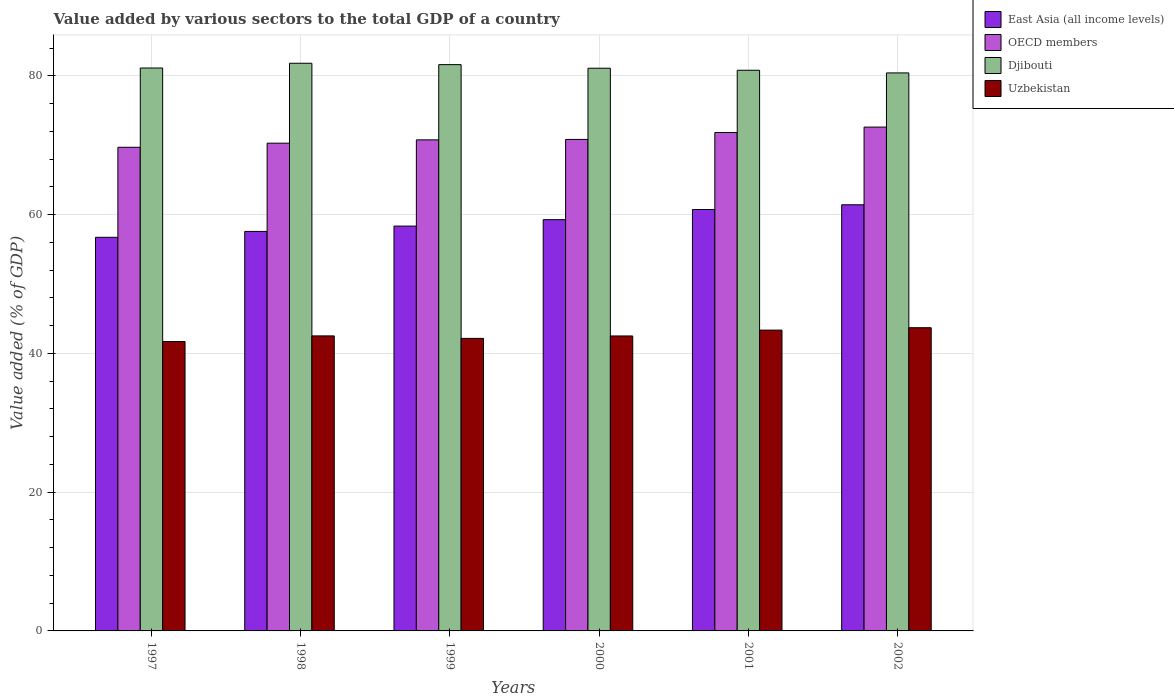Are the number of bars per tick equal to the number of legend labels?
Ensure brevity in your answer.  Yes. How many bars are there on the 6th tick from the left?
Give a very brief answer. 4. How many bars are there on the 5th tick from the right?
Give a very brief answer. 4. What is the label of the 6th group of bars from the left?
Your answer should be very brief. 2002. What is the value added by various sectors to the total GDP in Uzbekistan in 1999?
Ensure brevity in your answer.  42.17. Across all years, what is the maximum value added by various sectors to the total GDP in OECD members?
Provide a short and direct response. 72.62. Across all years, what is the minimum value added by various sectors to the total GDP in Djibouti?
Offer a very short reply. 80.43. What is the total value added by various sectors to the total GDP in Uzbekistan in the graph?
Offer a terse response. 255.98. What is the difference between the value added by various sectors to the total GDP in OECD members in 1997 and that in 1998?
Ensure brevity in your answer.  -0.59. What is the difference between the value added by various sectors to the total GDP in OECD members in 1997 and the value added by various sectors to the total GDP in Uzbekistan in 2002?
Give a very brief answer. 26.01. What is the average value added by various sectors to the total GDP in East Asia (all income levels) per year?
Give a very brief answer. 59.02. In the year 1997, what is the difference between the value added by various sectors to the total GDP in East Asia (all income levels) and value added by various sectors to the total GDP in OECD members?
Keep it short and to the point. -12.98. What is the ratio of the value added by various sectors to the total GDP in Uzbekistan in 1998 to that in 1999?
Ensure brevity in your answer.  1.01. Is the value added by various sectors to the total GDP in OECD members in 1999 less than that in 2002?
Your answer should be compact. Yes. What is the difference between the highest and the second highest value added by various sectors to the total GDP in Djibouti?
Ensure brevity in your answer.  0.2. What is the difference between the highest and the lowest value added by various sectors to the total GDP in East Asia (all income levels)?
Provide a short and direct response. 4.69. Is the sum of the value added by various sectors to the total GDP in OECD members in 1998 and 1999 greater than the maximum value added by various sectors to the total GDP in Uzbekistan across all years?
Your answer should be very brief. Yes. Is it the case that in every year, the sum of the value added by various sectors to the total GDP in Djibouti and value added by various sectors to the total GDP in East Asia (all income levels) is greater than the sum of value added by various sectors to the total GDP in Uzbekistan and value added by various sectors to the total GDP in OECD members?
Your response must be concise. No. What does the 3rd bar from the left in 1999 represents?
Ensure brevity in your answer.  Djibouti. What does the 2nd bar from the right in 2001 represents?
Provide a short and direct response. Djibouti. Is it the case that in every year, the sum of the value added by various sectors to the total GDP in Djibouti and value added by various sectors to the total GDP in Uzbekistan is greater than the value added by various sectors to the total GDP in OECD members?
Keep it short and to the point. Yes. What is the difference between two consecutive major ticks on the Y-axis?
Make the answer very short. 20. Does the graph contain any zero values?
Keep it short and to the point. No. Does the graph contain grids?
Provide a short and direct response. Yes. How many legend labels are there?
Your answer should be compact. 4. What is the title of the graph?
Your answer should be very brief. Value added by various sectors to the total GDP of a country. What is the label or title of the X-axis?
Your response must be concise. Years. What is the label or title of the Y-axis?
Make the answer very short. Value added (% of GDP). What is the Value added (% of GDP) of East Asia (all income levels) in 1997?
Ensure brevity in your answer.  56.73. What is the Value added (% of GDP) of OECD members in 1997?
Your answer should be compact. 69.71. What is the Value added (% of GDP) in Djibouti in 1997?
Keep it short and to the point. 81.14. What is the Value added (% of GDP) in Uzbekistan in 1997?
Offer a terse response. 41.71. What is the Value added (% of GDP) of East Asia (all income levels) in 1998?
Ensure brevity in your answer.  57.58. What is the Value added (% of GDP) in OECD members in 1998?
Provide a short and direct response. 70.3. What is the Value added (% of GDP) of Djibouti in 1998?
Offer a very short reply. 81.82. What is the Value added (% of GDP) of Uzbekistan in 1998?
Make the answer very short. 42.52. What is the Value added (% of GDP) of East Asia (all income levels) in 1999?
Your answer should be very brief. 58.35. What is the Value added (% of GDP) of OECD members in 1999?
Ensure brevity in your answer.  70.78. What is the Value added (% of GDP) in Djibouti in 1999?
Make the answer very short. 81.62. What is the Value added (% of GDP) in Uzbekistan in 1999?
Provide a succinct answer. 42.17. What is the Value added (% of GDP) in East Asia (all income levels) in 2000?
Your answer should be compact. 59.28. What is the Value added (% of GDP) in OECD members in 2000?
Your response must be concise. 70.84. What is the Value added (% of GDP) of Djibouti in 2000?
Your answer should be compact. 81.1. What is the Value added (% of GDP) of Uzbekistan in 2000?
Ensure brevity in your answer.  42.51. What is the Value added (% of GDP) of East Asia (all income levels) in 2001?
Your response must be concise. 60.74. What is the Value added (% of GDP) in OECD members in 2001?
Your response must be concise. 71.84. What is the Value added (% of GDP) of Djibouti in 2001?
Give a very brief answer. 80.81. What is the Value added (% of GDP) of Uzbekistan in 2001?
Give a very brief answer. 43.36. What is the Value added (% of GDP) in East Asia (all income levels) in 2002?
Make the answer very short. 61.42. What is the Value added (% of GDP) in OECD members in 2002?
Provide a succinct answer. 72.62. What is the Value added (% of GDP) of Djibouti in 2002?
Provide a short and direct response. 80.43. What is the Value added (% of GDP) of Uzbekistan in 2002?
Ensure brevity in your answer.  43.7. Across all years, what is the maximum Value added (% of GDP) of East Asia (all income levels)?
Offer a terse response. 61.42. Across all years, what is the maximum Value added (% of GDP) of OECD members?
Make the answer very short. 72.62. Across all years, what is the maximum Value added (% of GDP) in Djibouti?
Your answer should be very brief. 81.82. Across all years, what is the maximum Value added (% of GDP) of Uzbekistan?
Offer a terse response. 43.7. Across all years, what is the minimum Value added (% of GDP) of East Asia (all income levels)?
Offer a terse response. 56.73. Across all years, what is the minimum Value added (% of GDP) in OECD members?
Provide a succinct answer. 69.71. Across all years, what is the minimum Value added (% of GDP) of Djibouti?
Provide a short and direct response. 80.43. Across all years, what is the minimum Value added (% of GDP) in Uzbekistan?
Your answer should be compact. 41.71. What is the total Value added (% of GDP) of East Asia (all income levels) in the graph?
Offer a terse response. 354.11. What is the total Value added (% of GDP) of OECD members in the graph?
Make the answer very short. 426.1. What is the total Value added (% of GDP) of Djibouti in the graph?
Offer a terse response. 486.92. What is the total Value added (% of GDP) in Uzbekistan in the graph?
Ensure brevity in your answer.  255.98. What is the difference between the Value added (% of GDP) of East Asia (all income levels) in 1997 and that in 1998?
Offer a terse response. -0.85. What is the difference between the Value added (% of GDP) of OECD members in 1997 and that in 1998?
Keep it short and to the point. -0.59. What is the difference between the Value added (% of GDP) of Djibouti in 1997 and that in 1998?
Make the answer very short. -0.68. What is the difference between the Value added (% of GDP) of Uzbekistan in 1997 and that in 1998?
Offer a very short reply. -0.81. What is the difference between the Value added (% of GDP) in East Asia (all income levels) in 1997 and that in 1999?
Ensure brevity in your answer.  -1.62. What is the difference between the Value added (% of GDP) in OECD members in 1997 and that in 1999?
Your answer should be compact. -1.07. What is the difference between the Value added (% of GDP) in Djibouti in 1997 and that in 1999?
Make the answer very short. -0.49. What is the difference between the Value added (% of GDP) in Uzbekistan in 1997 and that in 1999?
Keep it short and to the point. -0.45. What is the difference between the Value added (% of GDP) of East Asia (all income levels) in 1997 and that in 2000?
Your response must be concise. -2.54. What is the difference between the Value added (% of GDP) of OECD members in 1997 and that in 2000?
Your answer should be compact. -1.13. What is the difference between the Value added (% of GDP) of Djibouti in 1997 and that in 2000?
Give a very brief answer. 0.03. What is the difference between the Value added (% of GDP) in Uzbekistan in 1997 and that in 2000?
Your answer should be very brief. -0.8. What is the difference between the Value added (% of GDP) in East Asia (all income levels) in 1997 and that in 2001?
Your response must be concise. -4.01. What is the difference between the Value added (% of GDP) in OECD members in 1997 and that in 2001?
Make the answer very short. -2.13. What is the difference between the Value added (% of GDP) of Djibouti in 1997 and that in 2001?
Your answer should be compact. 0.32. What is the difference between the Value added (% of GDP) in Uzbekistan in 1997 and that in 2001?
Make the answer very short. -1.65. What is the difference between the Value added (% of GDP) in East Asia (all income levels) in 1997 and that in 2002?
Your response must be concise. -4.69. What is the difference between the Value added (% of GDP) in OECD members in 1997 and that in 2002?
Make the answer very short. -2.91. What is the difference between the Value added (% of GDP) in Djibouti in 1997 and that in 2002?
Your response must be concise. 0.71. What is the difference between the Value added (% of GDP) of Uzbekistan in 1997 and that in 2002?
Your response must be concise. -1.99. What is the difference between the Value added (% of GDP) of East Asia (all income levels) in 1998 and that in 1999?
Ensure brevity in your answer.  -0.77. What is the difference between the Value added (% of GDP) in OECD members in 1998 and that in 1999?
Offer a very short reply. -0.48. What is the difference between the Value added (% of GDP) in Djibouti in 1998 and that in 1999?
Provide a short and direct response. 0.2. What is the difference between the Value added (% of GDP) of Uzbekistan in 1998 and that in 1999?
Your answer should be very brief. 0.36. What is the difference between the Value added (% of GDP) in East Asia (all income levels) in 1998 and that in 2000?
Offer a terse response. -1.69. What is the difference between the Value added (% of GDP) of OECD members in 1998 and that in 2000?
Provide a short and direct response. -0.54. What is the difference between the Value added (% of GDP) in Djibouti in 1998 and that in 2000?
Provide a succinct answer. 0.72. What is the difference between the Value added (% of GDP) in Uzbekistan in 1998 and that in 2000?
Your answer should be very brief. 0.01. What is the difference between the Value added (% of GDP) of East Asia (all income levels) in 1998 and that in 2001?
Offer a terse response. -3.16. What is the difference between the Value added (% of GDP) of OECD members in 1998 and that in 2001?
Give a very brief answer. -1.54. What is the difference between the Value added (% of GDP) of Djibouti in 1998 and that in 2001?
Ensure brevity in your answer.  1.01. What is the difference between the Value added (% of GDP) in Uzbekistan in 1998 and that in 2001?
Keep it short and to the point. -0.83. What is the difference between the Value added (% of GDP) in East Asia (all income levels) in 1998 and that in 2002?
Provide a succinct answer. -3.84. What is the difference between the Value added (% of GDP) in OECD members in 1998 and that in 2002?
Offer a very short reply. -2.32. What is the difference between the Value added (% of GDP) in Djibouti in 1998 and that in 2002?
Provide a short and direct response. 1.39. What is the difference between the Value added (% of GDP) of Uzbekistan in 1998 and that in 2002?
Provide a succinct answer. -1.18. What is the difference between the Value added (% of GDP) of East Asia (all income levels) in 1999 and that in 2000?
Your answer should be compact. -0.93. What is the difference between the Value added (% of GDP) of OECD members in 1999 and that in 2000?
Offer a very short reply. -0.06. What is the difference between the Value added (% of GDP) of Djibouti in 1999 and that in 2000?
Make the answer very short. 0.52. What is the difference between the Value added (% of GDP) in Uzbekistan in 1999 and that in 2000?
Provide a short and direct response. -0.35. What is the difference between the Value added (% of GDP) of East Asia (all income levels) in 1999 and that in 2001?
Your answer should be very brief. -2.39. What is the difference between the Value added (% of GDP) of OECD members in 1999 and that in 2001?
Offer a terse response. -1.06. What is the difference between the Value added (% of GDP) of Djibouti in 1999 and that in 2001?
Your answer should be very brief. 0.81. What is the difference between the Value added (% of GDP) of Uzbekistan in 1999 and that in 2001?
Your answer should be compact. -1.19. What is the difference between the Value added (% of GDP) of East Asia (all income levels) in 1999 and that in 2002?
Your answer should be compact. -3.07. What is the difference between the Value added (% of GDP) in OECD members in 1999 and that in 2002?
Give a very brief answer. -1.84. What is the difference between the Value added (% of GDP) of Djibouti in 1999 and that in 2002?
Your response must be concise. 1.19. What is the difference between the Value added (% of GDP) in Uzbekistan in 1999 and that in 2002?
Make the answer very short. -1.54. What is the difference between the Value added (% of GDP) of East Asia (all income levels) in 2000 and that in 2001?
Make the answer very short. -1.46. What is the difference between the Value added (% of GDP) of OECD members in 2000 and that in 2001?
Provide a succinct answer. -1. What is the difference between the Value added (% of GDP) of Djibouti in 2000 and that in 2001?
Keep it short and to the point. 0.29. What is the difference between the Value added (% of GDP) of Uzbekistan in 2000 and that in 2001?
Your answer should be compact. -0.84. What is the difference between the Value added (% of GDP) of East Asia (all income levels) in 2000 and that in 2002?
Make the answer very short. -2.15. What is the difference between the Value added (% of GDP) of OECD members in 2000 and that in 2002?
Provide a short and direct response. -1.78. What is the difference between the Value added (% of GDP) of Djibouti in 2000 and that in 2002?
Offer a terse response. 0.67. What is the difference between the Value added (% of GDP) in Uzbekistan in 2000 and that in 2002?
Offer a terse response. -1.19. What is the difference between the Value added (% of GDP) of East Asia (all income levels) in 2001 and that in 2002?
Offer a very short reply. -0.68. What is the difference between the Value added (% of GDP) of OECD members in 2001 and that in 2002?
Ensure brevity in your answer.  -0.78. What is the difference between the Value added (% of GDP) of Djibouti in 2001 and that in 2002?
Provide a short and direct response. 0.38. What is the difference between the Value added (% of GDP) of Uzbekistan in 2001 and that in 2002?
Make the answer very short. -0.35. What is the difference between the Value added (% of GDP) in East Asia (all income levels) in 1997 and the Value added (% of GDP) in OECD members in 1998?
Give a very brief answer. -13.57. What is the difference between the Value added (% of GDP) in East Asia (all income levels) in 1997 and the Value added (% of GDP) in Djibouti in 1998?
Provide a short and direct response. -25.09. What is the difference between the Value added (% of GDP) of East Asia (all income levels) in 1997 and the Value added (% of GDP) of Uzbekistan in 1998?
Ensure brevity in your answer.  14.21. What is the difference between the Value added (% of GDP) in OECD members in 1997 and the Value added (% of GDP) in Djibouti in 1998?
Offer a terse response. -12.11. What is the difference between the Value added (% of GDP) of OECD members in 1997 and the Value added (% of GDP) of Uzbekistan in 1998?
Your answer should be compact. 27.19. What is the difference between the Value added (% of GDP) of Djibouti in 1997 and the Value added (% of GDP) of Uzbekistan in 1998?
Ensure brevity in your answer.  38.61. What is the difference between the Value added (% of GDP) of East Asia (all income levels) in 1997 and the Value added (% of GDP) of OECD members in 1999?
Your answer should be compact. -14.05. What is the difference between the Value added (% of GDP) of East Asia (all income levels) in 1997 and the Value added (% of GDP) of Djibouti in 1999?
Provide a succinct answer. -24.89. What is the difference between the Value added (% of GDP) of East Asia (all income levels) in 1997 and the Value added (% of GDP) of Uzbekistan in 1999?
Your answer should be very brief. 14.57. What is the difference between the Value added (% of GDP) of OECD members in 1997 and the Value added (% of GDP) of Djibouti in 1999?
Ensure brevity in your answer.  -11.91. What is the difference between the Value added (% of GDP) in OECD members in 1997 and the Value added (% of GDP) in Uzbekistan in 1999?
Give a very brief answer. 27.54. What is the difference between the Value added (% of GDP) in Djibouti in 1997 and the Value added (% of GDP) in Uzbekistan in 1999?
Keep it short and to the point. 38.97. What is the difference between the Value added (% of GDP) in East Asia (all income levels) in 1997 and the Value added (% of GDP) in OECD members in 2000?
Offer a very short reply. -14.11. What is the difference between the Value added (% of GDP) in East Asia (all income levels) in 1997 and the Value added (% of GDP) in Djibouti in 2000?
Provide a short and direct response. -24.37. What is the difference between the Value added (% of GDP) in East Asia (all income levels) in 1997 and the Value added (% of GDP) in Uzbekistan in 2000?
Give a very brief answer. 14.22. What is the difference between the Value added (% of GDP) in OECD members in 1997 and the Value added (% of GDP) in Djibouti in 2000?
Your answer should be very brief. -11.39. What is the difference between the Value added (% of GDP) in OECD members in 1997 and the Value added (% of GDP) in Uzbekistan in 2000?
Provide a succinct answer. 27.2. What is the difference between the Value added (% of GDP) of Djibouti in 1997 and the Value added (% of GDP) of Uzbekistan in 2000?
Your answer should be very brief. 38.62. What is the difference between the Value added (% of GDP) in East Asia (all income levels) in 1997 and the Value added (% of GDP) in OECD members in 2001?
Provide a short and direct response. -15.11. What is the difference between the Value added (% of GDP) in East Asia (all income levels) in 1997 and the Value added (% of GDP) in Djibouti in 2001?
Keep it short and to the point. -24.08. What is the difference between the Value added (% of GDP) in East Asia (all income levels) in 1997 and the Value added (% of GDP) in Uzbekistan in 2001?
Your answer should be compact. 13.38. What is the difference between the Value added (% of GDP) in OECD members in 1997 and the Value added (% of GDP) in Djibouti in 2001?
Provide a succinct answer. -11.1. What is the difference between the Value added (% of GDP) in OECD members in 1997 and the Value added (% of GDP) in Uzbekistan in 2001?
Ensure brevity in your answer.  26.35. What is the difference between the Value added (% of GDP) of Djibouti in 1997 and the Value added (% of GDP) of Uzbekistan in 2001?
Provide a short and direct response. 37.78. What is the difference between the Value added (% of GDP) of East Asia (all income levels) in 1997 and the Value added (% of GDP) of OECD members in 2002?
Your response must be concise. -15.89. What is the difference between the Value added (% of GDP) in East Asia (all income levels) in 1997 and the Value added (% of GDP) in Djibouti in 2002?
Your answer should be compact. -23.7. What is the difference between the Value added (% of GDP) of East Asia (all income levels) in 1997 and the Value added (% of GDP) of Uzbekistan in 2002?
Your answer should be compact. 13.03. What is the difference between the Value added (% of GDP) of OECD members in 1997 and the Value added (% of GDP) of Djibouti in 2002?
Give a very brief answer. -10.72. What is the difference between the Value added (% of GDP) in OECD members in 1997 and the Value added (% of GDP) in Uzbekistan in 2002?
Offer a very short reply. 26.01. What is the difference between the Value added (% of GDP) of Djibouti in 1997 and the Value added (% of GDP) of Uzbekistan in 2002?
Your answer should be very brief. 37.43. What is the difference between the Value added (% of GDP) in East Asia (all income levels) in 1998 and the Value added (% of GDP) in OECD members in 1999?
Offer a terse response. -13.2. What is the difference between the Value added (% of GDP) in East Asia (all income levels) in 1998 and the Value added (% of GDP) in Djibouti in 1999?
Give a very brief answer. -24.04. What is the difference between the Value added (% of GDP) of East Asia (all income levels) in 1998 and the Value added (% of GDP) of Uzbekistan in 1999?
Provide a succinct answer. 15.42. What is the difference between the Value added (% of GDP) of OECD members in 1998 and the Value added (% of GDP) of Djibouti in 1999?
Make the answer very short. -11.32. What is the difference between the Value added (% of GDP) of OECD members in 1998 and the Value added (% of GDP) of Uzbekistan in 1999?
Your answer should be very brief. 28.14. What is the difference between the Value added (% of GDP) in Djibouti in 1998 and the Value added (% of GDP) in Uzbekistan in 1999?
Provide a succinct answer. 39.65. What is the difference between the Value added (% of GDP) in East Asia (all income levels) in 1998 and the Value added (% of GDP) in OECD members in 2000?
Provide a short and direct response. -13.26. What is the difference between the Value added (% of GDP) of East Asia (all income levels) in 1998 and the Value added (% of GDP) of Djibouti in 2000?
Your answer should be very brief. -23.52. What is the difference between the Value added (% of GDP) of East Asia (all income levels) in 1998 and the Value added (% of GDP) of Uzbekistan in 2000?
Give a very brief answer. 15.07. What is the difference between the Value added (% of GDP) in OECD members in 1998 and the Value added (% of GDP) in Uzbekistan in 2000?
Provide a short and direct response. 27.79. What is the difference between the Value added (% of GDP) in Djibouti in 1998 and the Value added (% of GDP) in Uzbekistan in 2000?
Offer a terse response. 39.3. What is the difference between the Value added (% of GDP) in East Asia (all income levels) in 1998 and the Value added (% of GDP) in OECD members in 2001?
Make the answer very short. -14.26. What is the difference between the Value added (% of GDP) of East Asia (all income levels) in 1998 and the Value added (% of GDP) of Djibouti in 2001?
Ensure brevity in your answer.  -23.23. What is the difference between the Value added (% of GDP) in East Asia (all income levels) in 1998 and the Value added (% of GDP) in Uzbekistan in 2001?
Your answer should be very brief. 14.23. What is the difference between the Value added (% of GDP) in OECD members in 1998 and the Value added (% of GDP) in Djibouti in 2001?
Your response must be concise. -10.51. What is the difference between the Value added (% of GDP) of OECD members in 1998 and the Value added (% of GDP) of Uzbekistan in 2001?
Offer a terse response. 26.95. What is the difference between the Value added (% of GDP) of Djibouti in 1998 and the Value added (% of GDP) of Uzbekistan in 2001?
Provide a succinct answer. 38.46. What is the difference between the Value added (% of GDP) in East Asia (all income levels) in 1998 and the Value added (% of GDP) in OECD members in 2002?
Offer a very short reply. -15.04. What is the difference between the Value added (% of GDP) in East Asia (all income levels) in 1998 and the Value added (% of GDP) in Djibouti in 2002?
Give a very brief answer. -22.85. What is the difference between the Value added (% of GDP) in East Asia (all income levels) in 1998 and the Value added (% of GDP) in Uzbekistan in 2002?
Provide a short and direct response. 13.88. What is the difference between the Value added (% of GDP) in OECD members in 1998 and the Value added (% of GDP) in Djibouti in 2002?
Ensure brevity in your answer.  -10.13. What is the difference between the Value added (% of GDP) of OECD members in 1998 and the Value added (% of GDP) of Uzbekistan in 2002?
Ensure brevity in your answer.  26.6. What is the difference between the Value added (% of GDP) of Djibouti in 1998 and the Value added (% of GDP) of Uzbekistan in 2002?
Make the answer very short. 38.12. What is the difference between the Value added (% of GDP) in East Asia (all income levels) in 1999 and the Value added (% of GDP) in OECD members in 2000?
Keep it short and to the point. -12.49. What is the difference between the Value added (% of GDP) in East Asia (all income levels) in 1999 and the Value added (% of GDP) in Djibouti in 2000?
Provide a succinct answer. -22.75. What is the difference between the Value added (% of GDP) in East Asia (all income levels) in 1999 and the Value added (% of GDP) in Uzbekistan in 2000?
Your answer should be very brief. 15.84. What is the difference between the Value added (% of GDP) of OECD members in 1999 and the Value added (% of GDP) of Djibouti in 2000?
Your response must be concise. -10.32. What is the difference between the Value added (% of GDP) in OECD members in 1999 and the Value added (% of GDP) in Uzbekistan in 2000?
Provide a succinct answer. 28.27. What is the difference between the Value added (% of GDP) in Djibouti in 1999 and the Value added (% of GDP) in Uzbekistan in 2000?
Ensure brevity in your answer.  39.11. What is the difference between the Value added (% of GDP) in East Asia (all income levels) in 1999 and the Value added (% of GDP) in OECD members in 2001?
Keep it short and to the point. -13.49. What is the difference between the Value added (% of GDP) in East Asia (all income levels) in 1999 and the Value added (% of GDP) in Djibouti in 2001?
Your answer should be compact. -22.46. What is the difference between the Value added (% of GDP) in East Asia (all income levels) in 1999 and the Value added (% of GDP) in Uzbekistan in 2001?
Provide a short and direct response. 14.99. What is the difference between the Value added (% of GDP) of OECD members in 1999 and the Value added (% of GDP) of Djibouti in 2001?
Make the answer very short. -10.03. What is the difference between the Value added (% of GDP) of OECD members in 1999 and the Value added (% of GDP) of Uzbekistan in 2001?
Provide a succinct answer. 27.42. What is the difference between the Value added (% of GDP) of Djibouti in 1999 and the Value added (% of GDP) of Uzbekistan in 2001?
Your answer should be compact. 38.26. What is the difference between the Value added (% of GDP) in East Asia (all income levels) in 1999 and the Value added (% of GDP) in OECD members in 2002?
Provide a succinct answer. -14.27. What is the difference between the Value added (% of GDP) of East Asia (all income levels) in 1999 and the Value added (% of GDP) of Djibouti in 2002?
Provide a succinct answer. -22.08. What is the difference between the Value added (% of GDP) in East Asia (all income levels) in 1999 and the Value added (% of GDP) in Uzbekistan in 2002?
Offer a very short reply. 14.65. What is the difference between the Value added (% of GDP) in OECD members in 1999 and the Value added (% of GDP) in Djibouti in 2002?
Keep it short and to the point. -9.65. What is the difference between the Value added (% of GDP) in OECD members in 1999 and the Value added (% of GDP) in Uzbekistan in 2002?
Provide a short and direct response. 27.08. What is the difference between the Value added (% of GDP) of Djibouti in 1999 and the Value added (% of GDP) of Uzbekistan in 2002?
Your answer should be compact. 37.92. What is the difference between the Value added (% of GDP) in East Asia (all income levels) in 2000 and the Value added (% of GDP) in OECD members in 2001?
Make the answer very short. -12.56. What is the difference between the Value added (% of GDP) of East Asia (all income levels) in 2000 and the Value added (% of GDP) of Djibouti in 2001?
Make the answer very short. -21.54. What is the difference between the Value added (% of GDP) of East Asia (all income levels) in 2000 and the Value added (% of GDP) of Uzbekistan in 2001?
Offer a very short reply. 15.92. What is the difference between the Value added (% of GDP) in OECD members in 2000 and the Value added (% of GDP) in Djibouti in 2001?
Offer a terse response. -9.97. What is the difference between the Value added (% of GDP) in OECD members in 2000 and the Value added (% of GDP) in Uzbekistan in 2001?
Make the answer very short. 27.49. What is the difference between the Value added (% of GDP) of Djibouti in 2000 and the Value added (% of GDP) of Uzbekistan in 2001?
Offer a very short reply. 37.75. What is the difference between the Value added (% of GDP) of East Asia (all income levels) in 2000 and the Value added (% of GDP) of OECD members in 2002?
Offer a terse response. -13.34. What is the difference between the Value added (% of GDP) of East Asia (all income levels) in 2000 and the Value added (% of GDP) of Djibouti in 2002?
Provide a succinct answer. -21.15. What is the difference between the Value added (% of GDP) of East Asia (all income levels) in 2000 and the Value added (% of GDP) of Uzbekistan in 2002?
Provide a short and direct response. 15.57. What is the difference between the Value added (% of GDP) of OECD members in 2000 and the Value added (% of GDP) of Djibouti in 2002?
Keep it short and to the point. -9.59. What is the difference between the Value added (% of GDP) in OECD members in 2000 and the Value added (% of GDP) in Uzbekistan in 2002?
Offer a terse response. 27.14. What is the difference between the Value added (% of GDP) of Djibouti in 2000 and the Value added (% of GDP) of Uzbekistan in 2002?
Make the answer very short. 37.4. What is the difference between the Value added (% of GDP) of East Asia (all income levels) in 2001 and the Value added (% of GDP) of OECD members in 2002?
Offer a terse response. -11.88. What is the difference between the Value added (% of GDP) in East Asia (all income levels) in 2001 and the Value added (% of GDP) in Djibouti in 2002?
Your answer should be compact. -19.69. What is the difference between the Value added (% of GDP) of East Asia (all income levels) in 2001 and the Value added (% of GDP) of Uzbekistan in 2002?
Ensure brevity in your answer.  17.04. What is the difference between the Value added (% of GDP) of OECD members in 2001 and the Value added (% of GDP) of Djibouti in 2002?
Ensure brevity in your answer.  -8.59. What is the difference between the Value added (% of GDP) in OECD members in 2001 and the Value added (% of GDP) in Uzbekistan in 2002?
Your answer should be very brief. 28.14. What is the difference between the Value added (% of GDP) in Djibouti in 2001 and the Value added (% of GDP) in Uzbekistan in 2002?
Your answer should be very brief. 37.11. What is the average Value added (% of GDP) of East Asia (all income levels) per year?
Ensure brevity in your answer.  59.02. What is the average Value added (% of GDP) of OECD members per year?
Your answer should be compact. 71.02. What is the average Value added (% of GDP) of Djibouti per year?
Your answer should be very brief. 81.15. What is the average Value added (% of GDP) of Uzbekistan per year?
Your response must be concise. 42.66. In the year 1997, what is the difference between the Value added (% of GDP) of East Asia (all income levels) and Value added (% of GDP) of OECD members?
Provide a short and direct response. -12.98. In the year 1997, what is the difference between the Value added (% of GDP) of East Asia (all income levels) and Value added (% of GDP) of Djibouti?
Offer a very short reply. -24.4. In the year 1997, what is the difference between the Value added (% of GDP) of East Asia (all income levels) and Value added (% of GDP) of Uzbekistan?
Ensure brevity in your answer.  15.02. In the year 1997, what is the difference between the Value added (% of GDP) in OECD members and Value added (% of GDP) in Djibouti?
Provide a short and direct response. -11.42. In the year 1997, what is the difference between the Value added (% of GDP) in OECD members and Value added (% of GDP) in Uzbekistan?
Provide a short and direct response. 28. In the year 1997, what is the difference between the Value added (% of GDP) in Djibouti and Value added (% of GDP) in Uzbekistan?
Your answer should be compact. 39.42. In the year 1998, what is the difference between the Value added (% of GDP) of East Asia (all income levels) and Value added (% of GDP) of OECD members?
Provide a short and direct response. -12.72. In the year 1998, what is the difference between the Value added (% of GDP) of East Asia (all income levels) and Value added (% of GDP) of Djibouti?
Make the answer very short. -24.24. In the year 1998, what is the difference between the Value added (% of GDP) in East Asia (all income levels) and Value added (% of GDP) in Uzbekistan?
Offer a very short reply. 15.06. In the year 1998, what is the difference between the Value added (% of GDP) in OECD members and Value added (% of GDP) in Djibouti?
Offer a very short reply. -11.52. In the year 1998, what is the difference between the Value added (% of GDP) in OECD members and Value added (% of GDP) in Uzbekistan?
Provide a short and direct response. 27.78. In the year 1998, what is the difference between the Value added (% of GDP) in Djibouti and Value added (% of GDP) in Uzbekistan?
Provide a succinct answer. 39.3. In the year 1999, what is the difference between the Value added (% of GDP) in East Asia (all income levels) and Value added (% of GDP) in OECD members?
Give a very brief answer. -12.43. In the year 1999, what is the difference between the Value added (% of GDP) of East Asia (all income levels) and Value added (% of GDP) of Djibouti?
Ensure brevity in your answer.  -23.27. In the year 1999, what is the difference between the Value added (% of GDP) of East Asia (all income levels) and Value added (% of GDP) of Uzbekistan?
Provide a succinct answer. 16.18. In the year 1999, what is the difference between the Value added (% of GDP) in OECD members and Value added (% of GDP) in Djibouti?
Provide a short and direct response. -10.84. In the year 1999, what is the difference between the Value added (% of GDP) in OECD members and Value added (% of GDP) in Uzbekistan?
Your answer should be very brief. 28.61. In the year 1999, what is the difference between the Value added (% of GDP) in Djibouti and Value added (% of GDP) in Uzbekistan?
Offer a very short reply. 39.46. In the year 2000, what is the difference between the Value added (% of GDP) in East Asia (all income levels) and Value added (% of GDP) in OECD members?
Offer a very short reply. -11.57. In the year 2000, what is the difference between the Value added (% of GDP) of East Asia (all income levels) and Value added (% of GDP) of Djibouti?
Offer a terse response. -21.83. In the year 2000, what is the difference between the Value added (% of GDP) in East Asia (all income levels) and Value added (% of GDP) in Uzbekistan?
Make the answer very short. 16.76. In the year 2000, what is the difference between the Value added (% of GDP) of OECD members and Value added (% of GDP) of Djibouti?
Your answer should be compact. -10.26. In the year 2000, what is the difference between the Value added (% of GDP) in OECD members and Value added (% of GDP) in Uzbekistan?
Offer a very short reply. 28.33. In the year 2000, what is the difference between the Value added (% of GDP) in Djibouti and Value added (% of GDP) in Uzbekistan?
Ensure brevity in your answer.  38.59. In the year 2001, what is the difference between the Value added (% of GDP) in East Asia (all income levels) and Value added (% of GDP) in OECD members?
Give a very brief answer. -11.1. In the year 2001, what is the difference between the Value added (% of GDP) of East Asia (all income levels) and Value added (% of GDP) of Djibouti?
Offer a terse response. -20.07. In the year 2001, what is the difference between the Value added (% of GDP) of East Asia (all income levels) and Value added (% of GDP) of Uzbekistan?
Ensure brevity in your answer.  17.38. In the year 2001, what is the difference between the Value added (% of GDP) of OECD members and Value added (% of GDP) of Djibouti?
Offer a terse response. -8.97. In the year 2001, what is the difference between the Value added (% of GDP) in OECD members and Value added (% of GDP) in Uzbekistan?
Provide a succinct answer. 28.48. In the year 2001, what is the difference between the Value added (% of GDP) in Djibouti and Value added (% of GDP) in Uzbekistan?
Offer a terse response. 37.45. In the year 2002, what is the difference between the Value added (% of GDP) in East Asia (all income levels) and Value added (% of GDP) in OECD members?
Keep it short and to the point. -11.2. In the year 2002, what is the difference between the Value added (% of GDP) of East Asia (all income levels) and Value added (% of GDP) of Djibouti?
Provide a succinct answer. -19.01. In the year 2002, what is the difference between the Value added (% of GDP) of East Asia (all income levels) and Value added (% of GDP) of Uzbekistan?
Keep it short and to the point. 17.72. In the year 2002, what is the difference between the Value added (% of GDP) of OECD members and Value added (% of GDP) of Djibouti?
Your answer should be very brief. -7.81. In the year 2002, what is the difference between the Value added (% of GDP) of OECD members and Value added (% of GDP) of Uzbekistan?
Make the answer very short. 28.92. In the year 2002, what is the difference between the Value added (% of GDP) in Djibouti and Value added (% of GDP) in Uzbekistan?
Your answer should be compact. 36.73. What is the ratio of the Value added (% of GDP) in East Asia (all income levels) in 1997 to that in 1998?
Your answer should be compact. 0.99. What is the ratio of the Value added (% of GDP) of Uzbekistan in 1997 to that in 1998?
Your answer should be compact. 0.98. What is the ratio of the Value added (% of GDP) in East Asia (all income levels) in 1997 to that in 1999?
Provide a succinct answer. 0.97. What is the ratio of the Value added (% of GDP) in OECD members in 1997 to that in 1999?
Make the answer very short. 0.98. What is the ratio of the Value added (% of GDP) in Uzbekistan in 1997 to that in 1999?
Your response must be concise. 0.99. What is the ratio of the Value added (% of GDP) in East Asia (all income levels) in 1997 to that in 2000?
Keep it short and to the point. 0.96. What is the ratio of the Value added (% of GDP) of OECD members in 1997 to that in 2000?
Give a very brief answer. 0.98. What is the ratio of the Value added (% of GDP) of Djibouti in 1997 to that in 2000?
Your answer should be compact. 1. What is the ratio of the Value added (% of GDP) of Uzbekistan in 1997 to that in 2000?
Your response must be concise. 0.98. What is the ratio of the Value added (% of GDP) of East Asia (all income levels) in 1997 to that in 2001?
Keep it short and to the point. 0.93. What is the ratio of the Value added (% of GDP) of OECD members in 1997 to that in 2001?
Keep it short and to the point. 0.97. What is the ratio of the Value added (% of GDP) of Djibouti in 1997 to that in 2001?
Make the answer very short. 1. What is the ratio of the Value added (% of GDP) of Uzbekistan in 1997 to that in 2001?
Keep it short and to the point. 0.96. What is the ratio of the Value added (% of GDP) in East Asia (all income levels) in 1997 to that in 2002?
Ensure brevity in your answer.  0.92. What is the ratio of the Value added (% of GDP) of OECD members in 1997 to that in 2002?
Ensure brevity in your answer.  0.96. What is the ratio of the Value added (% of GDP) of Djibouti in 1997 to that in 2002?
Make the answer very short. 1.01. What is the ratio of the Value added (% of GDP) in Uzbekistan in 1997 to that in 2002?
Ensure brevity in your answer.  0.95. What is the ratio of the Value added (% of GDP) in OECD members in 1998 to that in 1999?
Your answer should be very brief. 0.99. What is the ratio of the Value added (% of GDP) of Djibouti in 1998 to that in 1999?
Your answer should be compact. 1. What is the ratio of the Value added (% of GDP) of Uzbekistan in 1998 to that in 1999?
Offer a very short reply. 1.01. What is the ratio of the Value added (% of GDP) in East Asia (all income levels) in 1998 to that in 2000?
Ensure brevity in your answer.  0.97. What is the ratio of the Value added (% of GDP) in Djibouti in 1998 to that in 2000?
Offer a terse response. 1.01. What is the ratio of the Value added (% of GDP) of East Asia (all income levels) in 1998 to that in 2001?
Your answer should be very brief. 0.95. What is the ratio of the Value added (% of GDP) in OECD members in 1998 to that in 2001?
Give a very brief answer. 0.98. What is the ratio of the Value added (% of GDP) of Djibouti in 1998 to that in 2001?
Make the answer very short. 1.01. What is the ratio of the Value added (% of GDP) of Uzbekistan in 1998 to that in 2001?
Your answer should be very brief. 0.98. What is the ratio of the Value added (% of GDP) in OECD members in 1998 to that in 2002?
Offer a very short reply. 0.97. What is the ratio of the Value added (% of GDP) in Djibouti in 1998 to that in 2002?
Ensure brevity in your answer.  1.02. What is the ratio of the Value added (% of GDP) in East Asia (all income levels) in 1999 to that in 2000?
Offer a terse response. 0.98. What is the ratio of the Value added (% of GDP) in OECD members in 1999 to that in 2000?
Provide a short and direct response. 1. What is the ratio of the Value added (% of GDP) of Djibouti in 1999 to that in 2000?
Give a very brief answer. 1.01. What is the ratio of the Value added (% of GDP) of Uzbekistan in 1999 to that in 2000?
Your answer should be compact. 0.99. What is the ratio of the Value added (% of GDP) in East Asia (all income levels) in 1999 to that in 2001?
Make the answer very short. 0.96. What is the ratio of the Value added (% of GDP) in OECD members in 1999 to that in 2001?
Keep it short and to the point. 0.99. What is the ratio of the Value added (% of GDP) in Uzbekistan in 1999 to that in 2001?
Keep it short and to the point. 0.97. What is the ratio of the Value added (% of GDP) of East Asia (all income levels) in 1999 to that in 2002?
Provide a short and direct response. 0.95. What is the ratio of the Value added (% of GDP) in OECD members in 1999 to that in 2002?
Offer a terse response. 0.97. What is the ratio of the Value added (% of GDP) of Djibouti in 1999 to that in 2002?
Offer a terse response. 1.01. What is the ratio of the Value added (% of GDP) of Uzbekistan in 1999 to that in 2002?
Ensure brevity in your answer.  0.96. What is the ratio of the Value added (% of GDP) of East Asia (all income levels) in 2000 to that in 2001?
Offer a very short reply. 0.98. What is the ratio of the Value added (% of GDP) of OECD members in 2000 to that in 2001?
Provide a succinct answer. 0.99. What is the ratio of the Value added (% of GDP) of Djibouti in 2000 to that in 2001?
Offer a terse response. 1. What is the ratio of the Value added (% of GDP) of Uzbekistan in 2000 to that in 2001?
Provide a short and direct response. 0.98. What is the ratio of the Value added (% of GDP) in OECD members in 2000 to that in 2002?
Ensure brevity in your answer.  0.98. What is the ratio of the Value added (% of GDP) in Djibouti in 2000 to that in 2002?
Your response must be concise. 1.01. What is the ratio of the Value added (% of GDP) in Uzbekistan in 2000 to that in 2002?
Provide a succinct answer. 0.97. What is the ratio of the Value added (% of GDP) of East Asia (all income levels) in 2001 to that in 2002?
Offer a very short reply. 0.99. What is the ratio of the Value added (% of GDP) in OECD members in 2001 to that in 2002?
Offer a very short reply. 0.99. What is the ratio of the Value added (% of GDP) of Djibouti in 2001 to that in 2002?
Keep it short and to the point. 1. What is the difference between the highest and the second highest Value added (% of GDP) of East Asia (all income levels)?
Your response must be concise. 0.68. What is the difference between the highest and the second highest Value added (% of GDP) in OECD members?
Provide a succinct answer. 0.78. What is the difference between the highest and the second highest Value added (% of GDP) of Djibouti?
Provide a short and direct response. 0.2. What is the difference between the highest and the second highest Value added (% of GDP) in Uzbekistan?
Your response must be concise. 0.35. What is the difference between the highest and the lowest Value added (% of GDP) in East Asia (all income levels)?
Make the answer very short. 4.69. What is the difference between the highest and the lowest Value added (% of GDP) of OECD members?
Provide a short and direct response. 2.91. What is the difference between the highest and the lowest Value added (% of GDP) in Djibouti?
Your answer should be compact. 1.39. What is the difference between the highest and the lowest Value added (% of GDP) in Uzbekistan?
Provide a short and direct response. 1.99. 